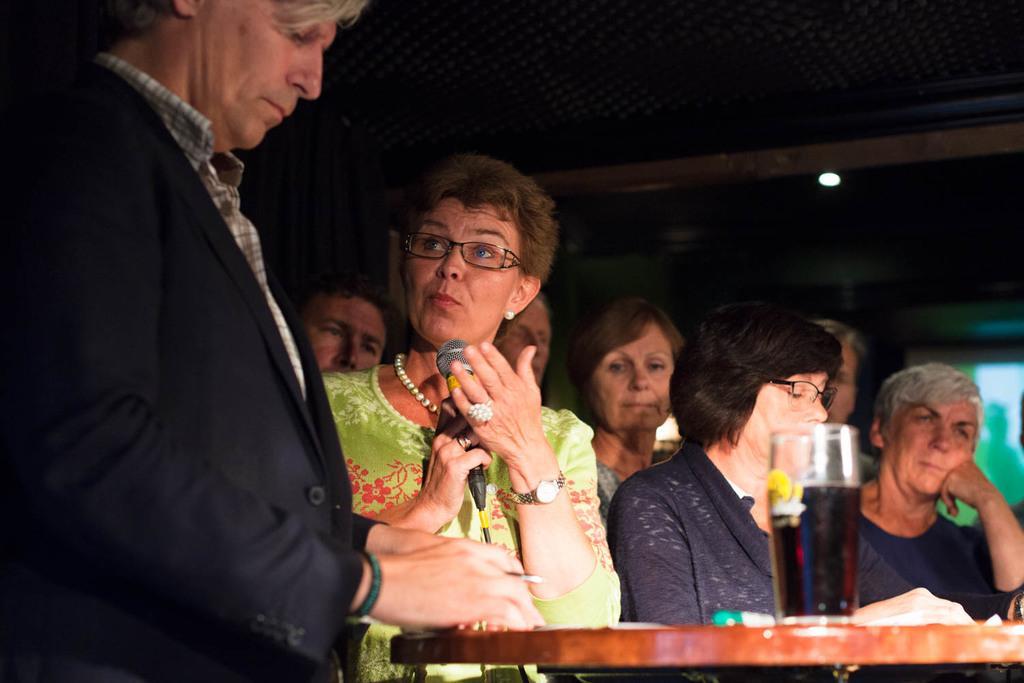Could you give a brief overview of what you see in this image? In this picture I can see group of people standing, there is a person holding a mike, there is a glass with a liquid in it, on the table, and in the background there are some objects. 